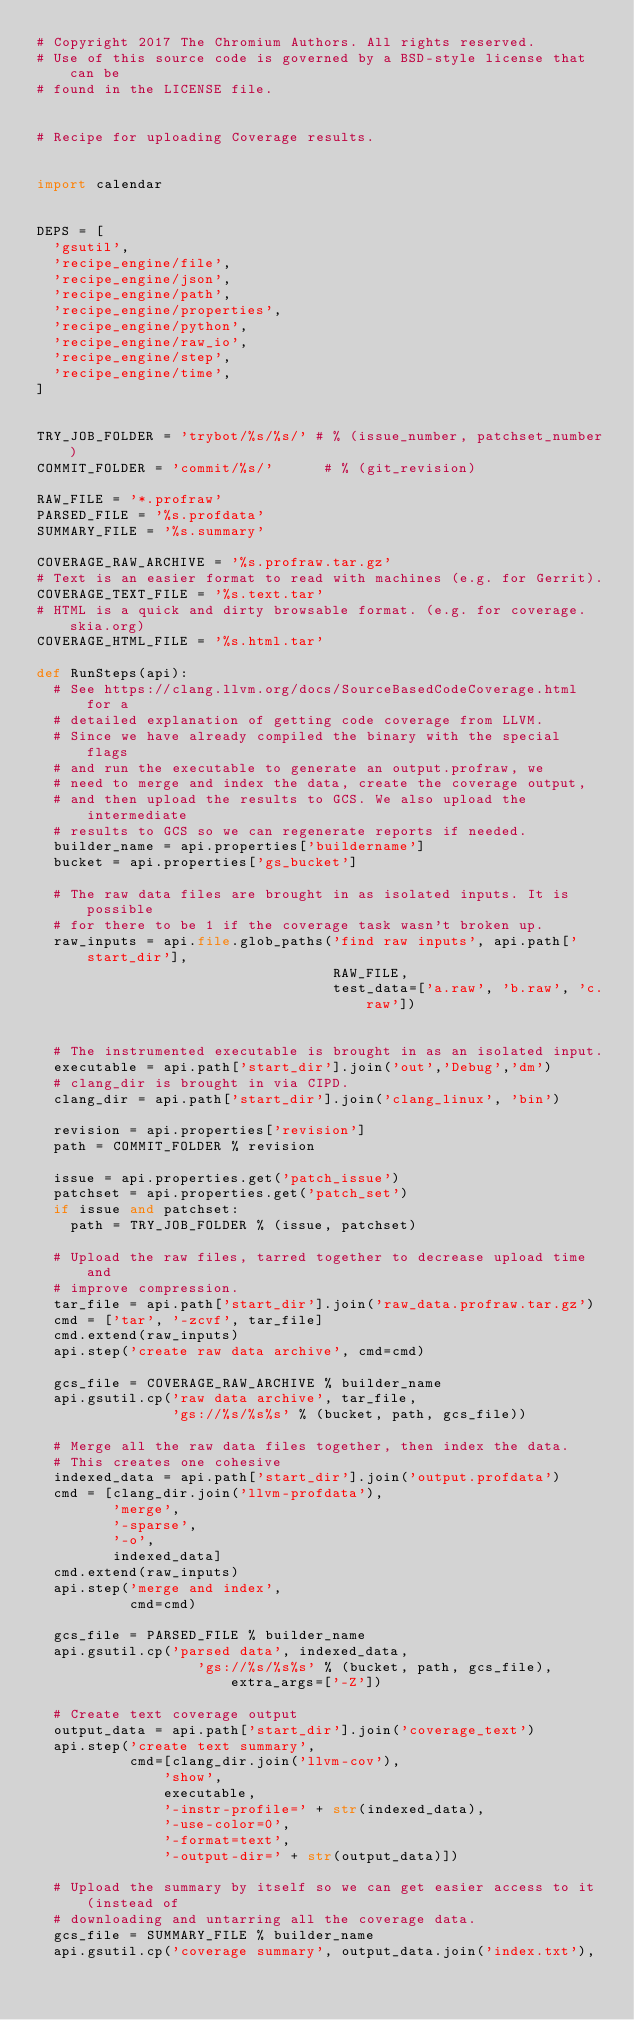Convert code to text. <code><loc_0><loc_0><loc_500><loc_500><_Python_># Copyright 2017 The Chromium Authors. All rights reserved.
# Use of this source code is governed by a BSD-style license that can be
# found in the LICENSE file.


# Recipe for uploading Coverage results.


import calendar


DEPS = [
  'gsutil',
  'recipe_engine/file',
  'recipe_engine/json',
  'recipe_engine/path',
  'recipe_engine/properties',
  'recipe_engine/python',
  'recipe_engine/raw_io',
  'recipe_engine/step',
  'recipe_engine/time',
]


TRY_JOB_FOLDER = 'trybot/%s/%s/' # % (issue_number, patchset_number)
COMMIT_FOLDER = 'commit/%s/'      # % (git_revision)

RAW_FILE = '*.profraw'
PARSED_FILE = '%s.profdata'
SUMMARY_FILE = '%s.summary'

COVERAGE_RAW_ARCHIVE = '%s.profraw.tar.gz'
# Text is an easier format to read with machines (e.g. for Gerrit).
COVERAGE_TEXT_FILE = '%s.text.tar'
# HTML is a quick and dirty browsable format. (e.g. for coverage.skia.org)
COVERAGE_HTML_FILE = '%s.html.tar'

def RunSteps(api):
  # See https://clang.llvm.org/docs/SourceBasedCodeCoverage.html for a
  # detailed explanation of getting code coverage from LLVM.
  # Since we have already compiled the binary with the special flags
  # and run the executable to generate an output.profraw, we
  # need to merge and index the data, create the coverage output,
  # and then upload the results to GCS. We also upload the intermediate
  # results to GCS so we can regenerate reports if needed.
  builder_name = api.properties['buildername']
  bucket = api.properties['gs_bucket']

  # The raw data files are brought in as isolated inputs. It is possible
  # for there to be 1 if the coverage task wasn't broken up.
  raw_inputs = api.file.glob_paths('find raw inputs', api.path['start_dir'],
                                   RAW_FILE,
                                   test_data=['a.raw', 'b.raw', 'c.raw'])


  # The instrumented executable is brought in as an isolated input.
  executable = api.path['start_dir'].join('out','Debug','dm')
  # clang_dir is brought in via CIPD.
  clang_dir = api.path['start_dir'].join('clang_linux', 'bin')

  revision = api.properties['revision']
  path = COMMIT_FOLDER % revision

  issue = api.properties.get('patch_issue')
  patchset = api.properties.get('patch_set')
  if issue and patchset:
    path = TRY_JOB_FOLDER % (issue, patchset)

  # Upload the raw files, tarred together to decrease upload time and
  # improve compression.
  tar_file = api.path['start_dir'].join('raw_data.profraw.tar.gz')
  cmd = ['tar', '-zcvf', tar_file]
  cmd.extend(raw_inputs)
  api.step('create raw data archive', cmd=cmd)

  gcs_file = COVERAGE_RAW_ARCHIVE % builder_name
  api.gsutil.cp('raw data archive', tar_file,
                'gs://%s/%s%s' % (bucket, path, gcs_file))

  # Merge all the raw data files together, then index the data.
  # This creates one cohesive
  indexed_data = api.path['start_dir'].join('output.profdata')
  cmd = [clang_dir.join('llvm-profdata'),
         'merge',
         '-sparse',
         '-o',
         indexed_data]
  cmd.extend(raw_inputs)
  api.step('merge and index',
           cmd=cmd)

  gcs_file = PARSED_FILE % builder_name
  api.gsutil.cp('parsed data', indexed_data,
                   'gs://%s/%s%s' % (bucket, path, gcs_file), extra_args=['-Z'])

  # Create text coverage output
  output_data = api.path['start_dir'].join('coverage_text')
  api.step('create text summary',
           cmd=[clang_dir.join('llvm-cov'),
               'show',
               executable,
               '-instr-profile=' + str(indexed_data),
               '-use-color=0',
               '-format=text',
               '-output-dir=' + str(output_data)])

  # Upload the summary by itself so we can get easier access to it (instead of
  # downloading and untarring all the coverage data.
  gcs_file = SUMMARY_FILE % builder_name
  api.gsutil.cp('coverage summary', output_data.join('index.txt'),</code> 